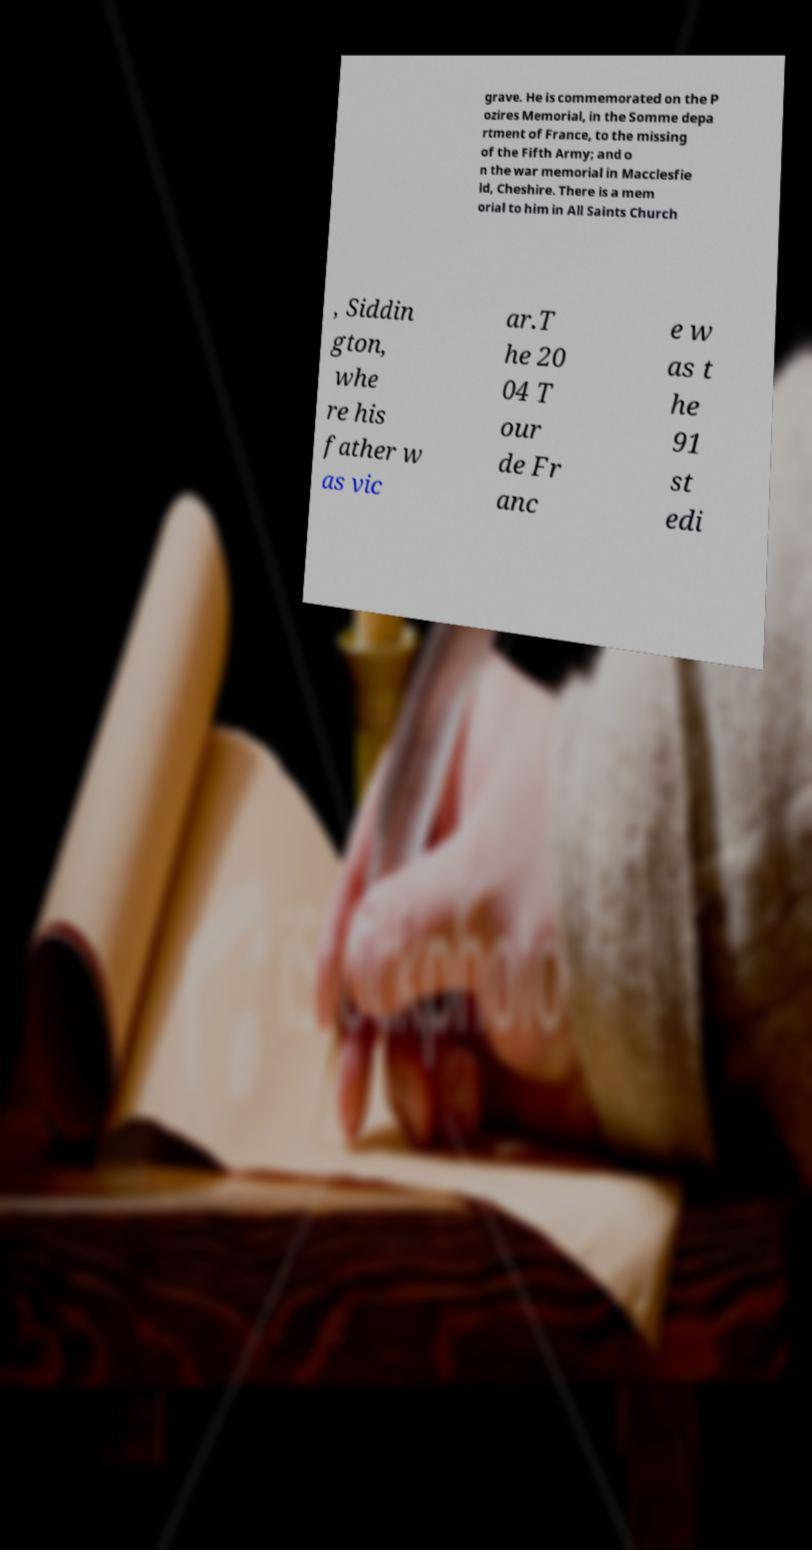I need the written content from this picture converted into text. Can you do that? grave. He is commemorated on the P ozires Memorial, in the Somme depa rtment of France, to the missing of the Fifth Army; and o n the war memorial in Macclesfie ld, Cheshire. There is a mem orial to him in All Saints Church , Siddin gton, whe re his father w as vic ar.T he 20 04 T our de Fr anc e w as t he 91 st edi 